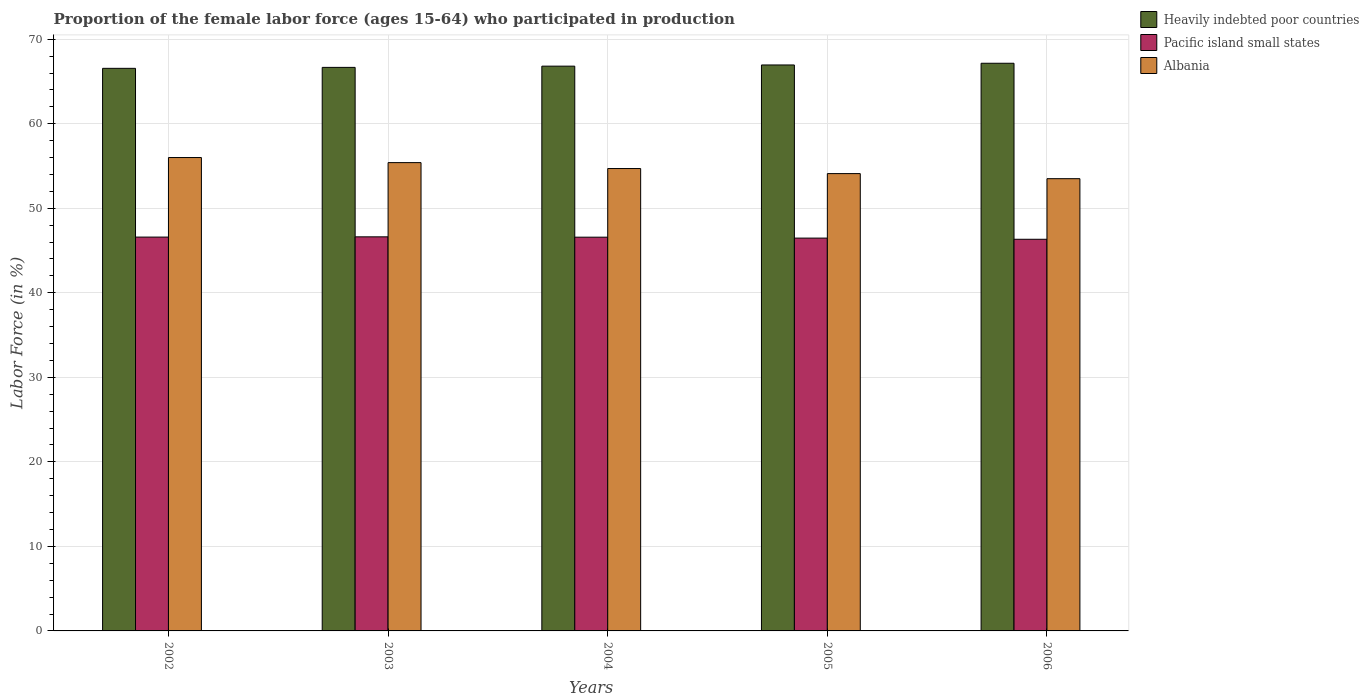How many groups of bars are there?
Offer a terse response. 5. Are the number of bars per tick equal to the number of legend labels?
Keep it short and to the point. Yes. How many bars are there on the 5th tick from the left?
Ensure brevity in your answer.  3. How many bars are there on the 5th tick from the right?
Your answer should be compact. 3. In how many cases, is the number of bars for a given year not equal to the number of legend labels?
Keep it short and to the point. 0. What is the proportion of the female labor force who participated in production in Albania in 2004?
Your answer should be compact. 54.7. Across all years, what is the maximum proportion of the female labor force who participated in production in Pacific island small states?
Your answer should be very brief. 46.62. Across all years, what is the minimum proportion of the female labor force who participated in production in Heavily indebted poor countries?
Ensure brevity in your answer.  66.55. In which year was the proportion of the female labor force who participated in production in Heavily indebted poor countries maximum?
Your answer should be very brief. 2006. In which year was the proportion of the female labor force who participated in production in Albania minimum?
Ensure brevity in your answer.  2006. What is the total proportion of the female labor force who participated in production in Albania in the graph?
Offer a terse response. 273.7. What is the difference between the proportion of the female labor force who participated in production in Albania in 2005 and the proportion of the female labor force who participated in production in Pacific island small states in 2004?
Your answer should be very brief. 7.52. What is the average proportion of the female labor force who participated in production in Heavily indebted poor countries per year?
Provide a short and direct response. 66.83. In the year 2005, what is the difference between the proportion of the female labor force who participated in production in Albania and proportion of the female labor force who participated in production in Heavily indebted poor countries?
Provide a succinct answer. -12.85. In how many years, is the proportion of the female labor force who participated in production in Heavily indebted poor countries greater than 66 %?
Ensure brevity in your answer.  5. What is the ratio of the proportion of the female labor force who participated in production in Albania in 2002 to that in 2004?
Give a very brief answer. 1.02. Is the difference between the proportion of the female labor force who participated in production in Albania in 2003 and 2005 greater than the difference between the proportion of the female labor force who participated in production in Heavily indebted poor countries in 2003 and 2005?
Your response must be concise. Yes. What is the difference between the highest and the second highest proportion of the female labor force who participated in production in Pacific island small states?
Give a very brief answer. 0.03. What is the difference between the highest and the lowest proportion of the female labor force who participated in production in Albania?
Your response must be concise. 2.5. In how many years, is the proportion of the female labor force who participated in production in Pacific island small states greater than the average proportion of the female labor force who participated in production in Pacific island small states taken over all years?
Your answer should be compact. 3. Is the sum of the proportion of the female labor force who participated in production in Pacific island small states in 2003 and 2005 greater than the maximum proportion of the female labor force who participated in production in Albania across all years?
Ensure brevity in your answer.  Yes. What does the 2nd bar from the left in 2003 represents?
Provide a succinct answer. Pacific island small states. What does the 2nd bar from the right in 2005 represents?
Ensure brevity in your answer.  Pacific island small states. Is it the case that in every year, the sum of the proportion of the female labor force who participated in production in Albania and proportion of the female labor force who participated in production in Pacific island small states is greater than the proportion of the female labor force who participated in production in Heavily indebted poor countries?
Ensure brevity in your answer.  Yes. How many bars are there?
Provide a short and direct response. 15. How many years are there in the graph?
Keep it short and to the point. 5. What is the difference between two consecutive major ticks on the Y-axis?
Your answer should be very brief. 10. Are the values on the major ticks of Y-axis written in scientific E-notation?
Your answer should be very brief. No. Does the graph contain any zero values?
Keep it short and to the point. No. How are the legend labels stacked?
Give a very brief answer. Vertical. What is the title of the graph?
Keep it short and to the point. Proportion of the female labor force (ages 15-64) who participated in production. Does "New Zealand" appear as one of the legend labels in the graph?
Keep it short and to the point. No. What is the label or title of the X-axis?
Offer a very short reply. Years. What is the label or title of the Y-axis?
Your answer should be compact. Labor Force (in %). What is the Labor Force (in %) in Heavily indebted poor countries in 2002?
Keep it short and to the point. 66.55. What is the Labor Force (in %) of Pacific island small states in 2002?
Give a very brief answer. 46.59. What is the Labor Force (in %) of Heavily indebted poor countries in 2003?
Ensure brevity in your answer.  66.67. What is the Labor Force (in %) in Pacific island small states in 2003?
Your response must be concise. 46.62. What is the Labor Force (in %) in Albania in 2003?
Offer a terse response. 55.4. What is the Labor Force (in %) of Heavily indebted poor countries in 2004?
Keep it short and to the point. 66.81. What is the Labor Force (in %) in Pacific island small states in 2004?
Your answer should be very brief. 46.58. What is the Labor Force (in %) in Albania in 2004?
Your answer should be very brief. 54.7. What is the Labor Force (in %) of Heavily indebted poor countries in 2005?
Provide a succinct answer. 66.95. What is the Labor Force (in %) of Pacific island small states in 2005?
Make the answer very short. 46.47. What is the Labor Force (in %) in Albania in 2005?
Your answer should be very brief. 54.1. What is the Labor Force (in %) in Heavily indebted poor countries in 2006?
Ensure brevity in your answer.  67.15. What is the Labor Force (in %) in Pacific island small states in 2006?
Provide a succinct answer. 46.33. What is the Labor Force (in %) of Albania in 2006?
Your response must be concise. 53.5. Across all years, what is the maximum Labor Force (in %) in Heavily indebted poor countries?
Your answer should be very brief. 67.15. Across all years, what is the maximum Labor Force (in %) of Pacific island small states?
Your answer should be very brief. 46.62. Across all years, what is the minimum Labor Force (in %) in Heavily indebted poor countries?
Your answer should be very brief. 66.55. Across all years, what is the minimum Labor Force (in %) of Pacific island small states?
Offer a very short reply. 46.33. Across all years, what is the minimum Labor Force (in %) in Albania?
Give a very brief answer. 53.5. What is the total Labor Force (in %) in Heavily indebted poor countries in the graph?
Keep it short and to the point. 334.14. What is the total Labor Force (in %) in Pacific island small states in the graph?
Your answer should be very brief. 232.59. What is the total Labor Force (in %) in Albania in the graph?
Offer a very short reply. 273.7. What is the difference between the Labor Force (in %) in Heavily indebted poor countries in 2002 and that in 2003?
Provide a short and direct response. -0.11. What is the difference between the Labor Force (in %) in Pacific island small states in 2002 and that in 2003?
Your answer should be very brief. -0.03. What is the difference between the Labor Force (in %) in Heavily indebted poor countries in 2002 and that in 2004?
Your response must be concise. -0.26. What is the difference between the Labor Force (in %) in Pacific island small states in 2002 and that in 2004?
Offer a terse response. 0.01. What is the difference between the Labor Force (in %) of Albania in 2002 and that in 2004?
Ensure brevity in your answer.  1.3. What is the difference between the Labor Force (in %) of Heavily indebted poor countries in 2002 and that in 2005?
Keep it short and to the point. -0.4. What is the difference between the Labor Force (in %) of Pacific island small states in 2002 and that in 2005?
Make the answer very short. 0.12. What is the difference between the Labor Force (in %) of Heavily indebted poor countries in 2002 and that in 2006?
Ensure brevity in your answer.  -0.6. What is the difference between the Labor Force (in %) of Pacific island small states in 2002 and that in 2006?
Your answer should be compact. 0.26. What is the difference between the Labor Force (in %) of Albania in 2002 and that in 2006?
Make the answer very short. 2.5. What is the difference between the Labor Force (in %) in Heavily indebted poor countries in 2003 and that in 2004?
Provide a succinct answer. -0.15. What is the difference between the Labor Force (in %) of Pacific island small states in 2003 and that in 2004?
Offer a very short reply. 0.04. What is the difference between the Labor Force (in %) of Albania in 2003 and that in 2004?
Ensure brevity in your answer.  0.7. What is the difference between the Labor Force (in %) of Heavily indebted poor countries in 2003 and that in 2005?
Give a very brief answer. -0.29. What is the difference between the Labor Force (in %) in Pacific island small states in 2003 and that in 2005?
Ensure brevity in your answer.  0.15. What is the difference between the Labor Force (in %) in Heavily indebted poor countries in 2003 and that in 2006?
Your answer should be compact. -0.49. What is the difference between the Labor Force (in %) in Pacific island small states in 2003 and that in 2006?
Your response must be concise. 0.29. What is the difference between the Labor Force (in %) in Heavily indebted poor countries in 2004 and that in 2005?
Provide a short and direct response. -0.14. What is the difference between the Labor Force (in %) in Pacific island small states in 2004 and that in 2005?
Your answer should be very brief. 0.11. What is the difference between the Labor Force (in %) of Heavily indebted poor countries in 2004 and that in 2006?
Your answer should be very brief. -0.34. What is the difference between the Labor Force (in %) in Pacific island small states in 2004 and that in 2006?
Provide a succinct answer. 0.25. What is the difference between the Labor Force (in %) of Albania in 2004 and that in 2006?
Provide a succinct answer. 1.2. What is the difference between the Labor Force (in %) of Heavily indebted poor countries in 2005 and that in 2006?
Provide a short and direct response. -0.2. What is the difference between the Labor Force (in %) in Pacific island small states in 2005 and that in 2006?
Keep it short and to the point. 0.14. What is the difference between the Labor Force (in %) in Albania in 2005 and that in 2006?
Keep it short and to the point. 0.6. What is the difference between the Labor Force (in %) in Heavily indebted poor countries in 2002 and the Labor Force (in %) in Pacific island small states in 2003?
Provide a short and direct response. 19.93. What is the difference between the Labor Force (in %) in Heavily indebted poor countries in 2002 and the Labor Force (in %) in Albania in 2003?
Give a very brief answer. 11.15. What is the difference between the Labor Force (in %) in Pacific island small states in 2002 and the Labor Force (in %) in Albania in 2003?
Keep it short and to the point. -8.81. What is the difference between the Labor Force (in %) in Heavily indebted poor countries in 2002 and the Labor Force (in %) in Pacific island small states in 2004?
Your answer should be compact. 19.97. What is the difference between the Labor Force (in %) of Heavily indebted poor countries in 2002 and the Labor Force (in %) of Albania in 2004?
Make the answer very short. 11.85. What is the difference between the Labor Force (in %) of Pacific island small states in 2002 and the Labor Force (in %) of Albania in 2004?
Keep it short and to the point. -8.11. What is the difference between the Labor Force (in %) in Heavily indebted poor countries in 2002 and the Labor Force (in %) in Pacific island small states in 2005?
Offer a terse response. 20.08. What is the difference between the Labor Force (in %) of Heavily indebted poor countries in 2002 and the Labor Force (in %) of Albania in 2005?
Keep it short and to the point. 12.45. What is the difference between the Labor Force (in %) in Pacific island small states in 2002 and the Labor Force (in %) in Albania in 2005?
Ensure brevity in your answer.  -7.51. What is the difference between the Labor Force (in %) in Heavily indebted poor countries in 2002 and the Labor Force (in %) in Pacific island small states in 2006?
Your answer should be compact. 20.22. What is the difference between the Labor Force (in %) of Heavily indebted poor countries in 2002 and the Labor Force (in %) of Albania in 2006?
Your answer should be very brief. 13.05. What is the difference between the Labor Force (in %) of Pacific island small states in 2002 and the Labor Force (in %) of Albania in 2006?
Provide a succinct answer. -6.91. What is the difference between the Labor Force (in %) in Heavily indebted poor countries in 2003 and the Labor Force (in %) in Pacific island small states in 2004?
Your response must be concise. 20.09. What is the difference between the Labor Force (in %) in Heavily indebted poor countries in 2003 and the Labor Force (in %) in Albania in 2004?
Your response must be concise. 11.97. What is the difference between the Labor Force (in %) in Pacific island small states in 2003 and the Labor Force (in %) in Albania in 2004?
Provide a succinct answer. -8.08. What is the difference between the Labor Force (in %) in Heavily indebted poor countries in 2003 and the Labor Force (in %) in Pacific island small states in 2005?
Keep it short and to the point. 20.2. What is the difference between the Labor Force (in %) in Heavily indebted poor countries in 2003 and the Labor Force (in %) in Albania in 2005?
Keep it short and to the point. 12.57. What is the difference between the Labor Force (in %) in Pacific island small states in 2003 and the Labor Force (in %) in Albania in 2005?
Ensure brevity in your answer.  -7.48. What is the difference between the Labor Force (in %) of Heavily indebted poor countries in 2003 and the Labor Force (in %) of Pacific island small states in 2006?
Keep it short and to the point. 20.33. What is the difference between the Labor Force (in %) in Heavily indebted poor countries in 2003 and the Labor Force (in %) in Albania in 2006?
Offer a terse response. 13.17. What is the difference between the Labor Force (in %) in Pacific island small states in 2003 and the Labor Force (in %) in Albania in 2006?
Your response must be concise. -6.88. What is the difference between the Labor Force (in %) of Heavily indebted poor countries in 2004 and the Labor Force (in %) of Pacific island small states in 2005?
Give a very brief answer. 20.34. What is the difference between the Labor Force (in %) in Heavily indebted poor countries in 2004 and the Labor Force (in %) in Albania in 2005?
Offer a terse response. 12.71. What is the difference between the Labor Force (in %) in Pacific island small states in 2004 and the Labor Force (in %) in Albania in 2005?
Make the answer very short. -7.52. What is the difference between the Labor Force (in %) of Heavily indebted poor countries in 2004 and the Labor Force (in %) of Pacific island small states in 2006?
Provide a succinct answer. 20.48. What is the difference between the Labor Force (in %) in Heavily indebted poor countries in 2004 and the Labor Force (in %) in Albania in 2006?
Offer a terse response. 13.31. What is the difference between the Labor Force (in %) in Pacific island small states in 2004 and the Labor Force (in %) in Albania in 2006?
Offer a very short reply. -6.92. What is the difference between the Labor Force (in %) in Heavily indebted poor countries in 2005 and the Labor Force (in %) in Pacific island small states in 2006?
Keep it short and to the point. 20.62. What is the difference between the Labor Force (in %) in Heavily indebted poor countries in 2005 and the Labor Force (in %) in Albania in 2006?
Your answer should be very brief. 13.45. What is the difference between the Labor Force (in %) of Pacific island small states in 2005 and the Labor Force (in %) of Albania in 2006?
Your answer should be very brief. -7.03. What is the average Labor Force (in %) of Heavily indebted poor countries per year?
Give a very brief answer. 66.83. What is the average Labor Force (in %) of Pacific island small states per year?
Your answer should be very brief. 46.52. What is the average Labor Force (in %) of Albania per year?
Keep it short and to the point. 54.74. In the year 2002, what is the difference between the Labor Force (in %) of Heavily indebted poor countries and Labor Force (in %) of Pacific island small states?
Provide a succinct answer. 19.96. In the year 2002, what is the difference between the Labor Force (in %) of Heavily indebted poor countries and Labor Force (in %) of Albania?
Your response must be concise. 10.55. In the year 2002, what is the difference between the Labor Force (in %) in Pacific island small states and Labor Force (in %) in Albania?
Your response must be concise. -9.41. In the year 2003, what is the difference between the Labor Force (in %) of Heavily indebted poor countries and Labor Force (in %) of Pacific island small states?
Ensure brevity in your answer.  20.05. In the year 2003, what is the difference between the Labor Force (in %) of Heavily indebted poor countries and Labor Force (in %) of Albania?
Give a very brief answer. 11.27. In the year 2003, what is the difference between the Labor Force (in %) of Pacific island small states and Labor Force (in %) of Albania?
Offer a terse response. -8.78. In the year 2004, what is the difference between the Labor Force (in %) of Heavily indebted poor countries and Labor Force (in %) of Pacific island small states?
Provide a succinct answer. 20.23. In the year 2004, what is the difference between the Labor Force (in %) of Heavily indebted poor countries and Labor Force (in %) of Albania?
Make the answer very short. 12.11. In the year 2004, what is the difference between the Labor Force (in %) of Pacific island small states and Labor Force (in %) of Albania?
Give a very brief answer. -8.12. In the year 2005, what is the difference between the Labor Force (in %) in Heavily indebted poor countries and Labor Force (in %) in Pacific island small states?
Provide a short and direct response. 20.48. In the year 2005, what is the difference between the Labor Force (in %) in Heavily indebted poor countries and Labor Force (in %) in Albania?
Your answer should be very brief. 12.85. In the year 2005, what is the difference between the Labor Force (in %) in Pacific island small states and Labor Force (in %) in Albania?
Give a very brief answer. -7.63. In the year 2006, what is the difference between the Labor Force (in %) of Heavily indebted poor countries and Labor Force (in %) of Pacific island small states?
Your answer should be compact. 20.82. In the year 2006, what is the difference between the Labor Force (in %) of Heavily indebted poor countries and Labor Force (in %) of Albania?
Make the answer very short. 13.65. In the year 2006, what is the difference between the Labor Force (in %) of Pacific island small states and Labor Force (in %) of Albania?
Provide a short and direct response. -7.17. What is the ratio of the Labor Force (in %) of Pacific island small states in 2002 to that in 2003?
Offer a terse response. 1. What is the ratio of the Labor Force (in %) in Albania in 2002 to that in 2003?
Provide a short and direct response. 1.01. What is the ratio of the Labor Force (in %) in Albania in 2002 to that in 2004?
Offer a very short reply. 1.02. What is the ratio of the Labor Force (in %) in Pacific island small states in 2002 to that in 2005?
Provide a succinct answer. 1. What is the ratio of the Labor Force (in %) of Albania in 2002 to that in 2005?
Your response must be concise. 1.04. What is the ratio of the Labor Force (in %) in Pacific island small states in 2002 to that in 2006?
Your response must be concise. 1.01. What is the ratio of the Labor Force (in %) in Albania in 2002 to that in 2006?
Provide a succinct answer. 1.05. What is the ratio of the Labor Force (in %) in Albania in 2003 to that in 2004?
Provide a short and direct response. 1.01. What is the ratio of the Labor Force (in %) of Heavily indebted poor countries in 2003 to that in 2005?
Make the answer very short. 1. What is the ratio of the Labor Force (in %) of Albania in 2003 to that in 2005?
Keep it short and to the point. 1.02. What is the ratio of the Labor Force (in %) of Pacific island small states in 2003 to that in 2006?
Make the answer very short. 1.01. What is the ratio of the Labor Force (in %) of Albania in 2003 to that in 2006?
Provide a succinct answer. 1.04. What is the ratio of the Labor Force (in %) of Heavily indebted poor countries in 2004 to that in 2005?
Your answer should be very brief. 1. What is the ratio of the Labor Force (in %) of Pacific island small states in 2004 to that in 2005?
Keep it short and to the point. 1. What is the ratio of the Labor Force (in %) of Albania in 2004 to that in 2005?
Give a very brief answer. 1.01. What is the ratio of the Labor Force (in %) in Pacific island small states in 2004 to that in 2006?
Offer a terse response. 1.01. What is the ratio of the Labor Force (in %) of Albania in 2004 to that in 2006?
Give a very brief answer. 1.02. What is the ratio of the Labor Force (in %) in Heavily indebted poor countries in 2005 to that in 2006?
Keep it short and to the point. 1. What is the ratio of the Labor Force (in %) of Pacific island small states in 2005 to that in 2006?
Provide a short and direct response. 1. What is the ratio of the Labor Force (in %) in Albania in 2005 to that in 2006?
Keep it short and to the point. 1.01. What is the difference between the highest and the second highest Labor Force (in %) of Heavily indebted poor countries?
Your response must be concise. 0.2. What is the difference between the highest and the second highest Labor Force (in %) of Pacific island small states?
Give a very brief answer. 0.03. What is the difference between the highest and the second highest Labor Force (in %) of Albania?
Make the answer very short. 0.6. What is the difference between the highest and the lowest Labor Force (in %) of Heavily indebted poor countries?
Provide a short and direct response. 0.6. What is the difference between the highest and the lowest Labor Force (in %) in Pacific island small states?
Provide a succinct answer. 0.29. What is the difference between the highest and the lowest Labor Force (in %) of Albania?
Keep it short and to the point. 2.5. 